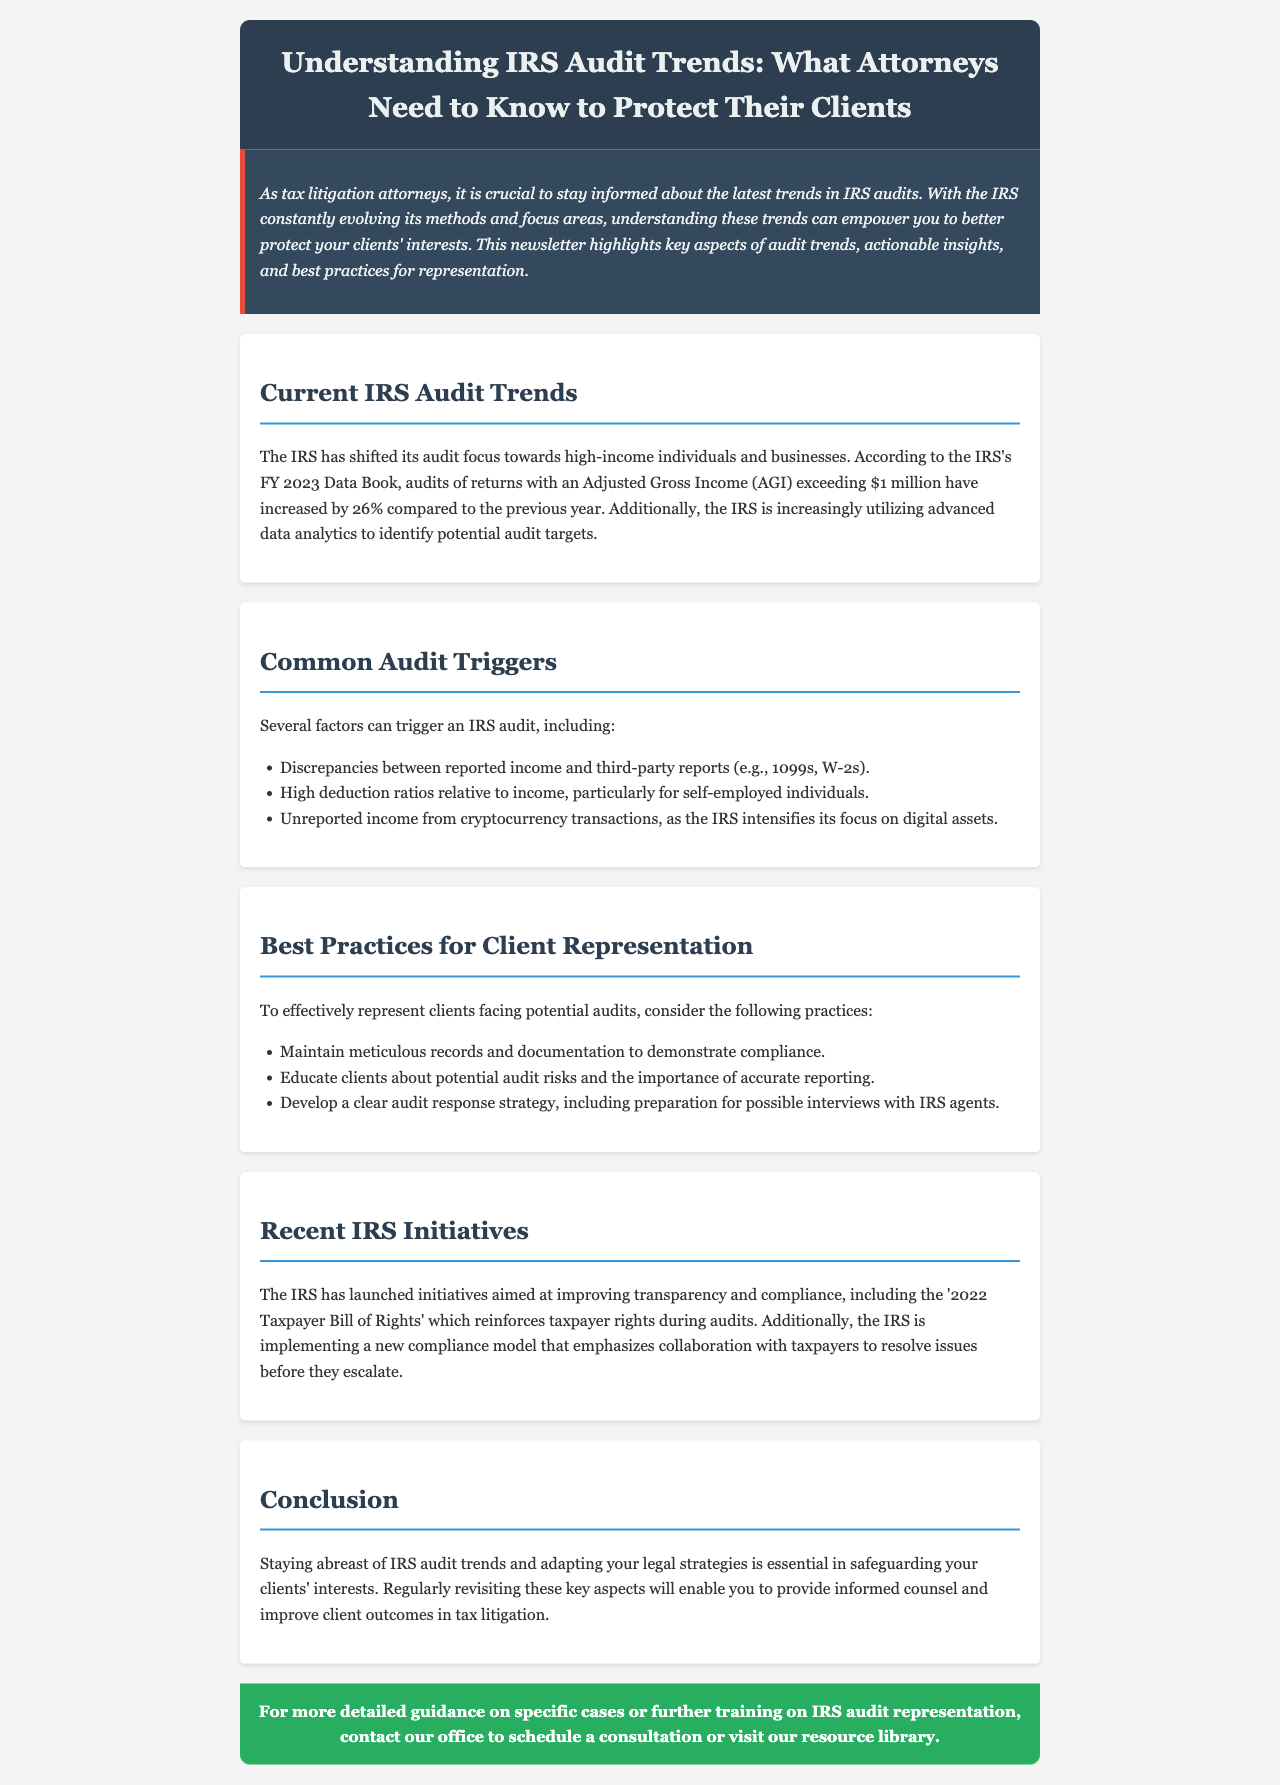What is the main focus of the IRS in audits? The document states that the IRS has shifted its audit focus towards high-income individuals and businesses.
Answer: High-income individuals and businesses What percentage increase in audits of returns with AGI over $1 million occurred from the previous year? The document mentions that audits of returns with an AGI exceeding $1 million have increased by 26% compared to the previous year.
Answer: 26% What should clients maintain to demonstrate compliance during audits? The best practice outlined for client representation emphasizes maintaining meticulous records and documentation.
Answer: Meticulous records and documentation Which digital asset is specifically mentioned as a focus for the IRS? The document specifies that the IRS is intensifying its focus on unreported income from cryptocurrency transactions.
Answer: Cryptocurrency What initiative reinforces taxpayer rights during audits? The document refers to the '2022 Taxpayer Bill of Rights' as an initiative aimed at improving transparency and compliance.
Answer: 2022 Taxpayer Bill of Rights What is a recommended strategy for client representation in potential audits? The document suggests developing a clear audit response strategy as part of best practices for representation.
Answer: Clear audit response strategy What key aspect does the introduction highlight for tax litigation attorneys? The introduction states the importance of staying informed about the latest trends in IRS audits.
Answer: Staying informed about audit trends What type of model is the IRS implementing for compliance? The document mentions that the IRS is implementing a new compliance model that emphasizes collaboration with taxpayers.
Answer: New compliance model 